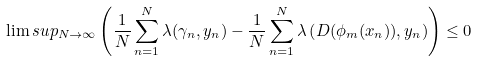<formula> <loc_0><loc_0><loc_500><loc_500>\lim s u p _ { N \to \infty } \left ( \frac { 1 } { N } \sum _ { n = 1 } ^ { N } \lambda ( \gamma _ { n } , y _ { n } ) - \frac { 1 } { N } \sum _ { n = 1 } ^ { N } \lambda \left ( D ( \phi _ { m } ( x _ { n } ) ) , y _ { n } \right ) \right ) \leq 0</formula> 